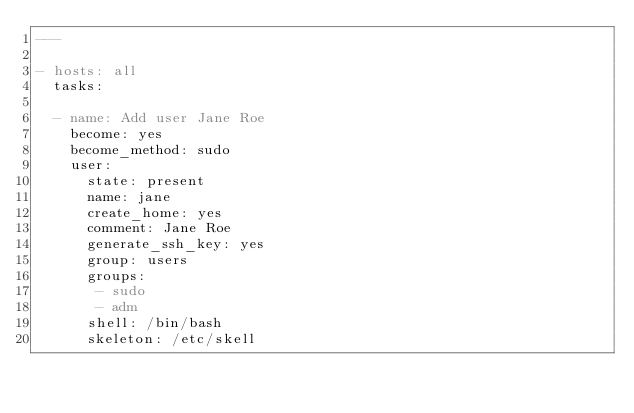Convert code to text. <code><loc_0><loc_0><loc_500><loc_500><_YAML_>---

- hosts: all
  tasks:

  - name: Add user Jane Roe
    become: yes
    become_method: sudo
    user:
      state: present
      name: jane
      create_home: yes
      comment: Jane Roe
      generate_ssh_key: yes
      group: users
      groups:
       - sudo
       - adm
      shell: /bin/bash
      skeleton: /etc/skell
</code> 